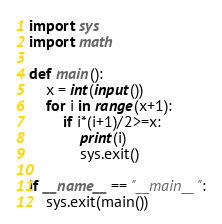Convert code to text. <code><loc_0><loc_0><loc_500><loc_500><_Python_>import sys
import math

def main():
    x = int(input())
    for i in range(x+1):
        if i*(i+1)/2>=x:
            print(i)
            sys.exit()

if __name__ == "__main__":
    sys.exit(main())

</code> 